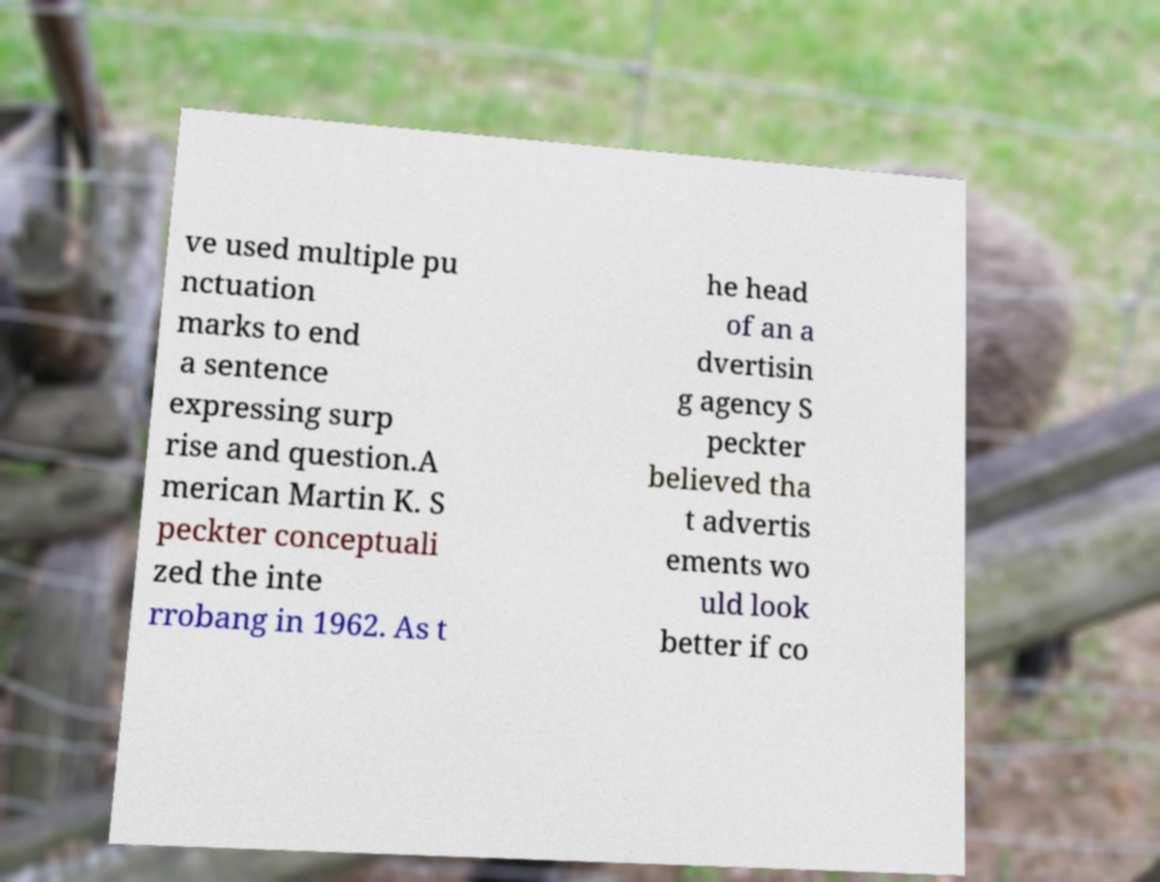Please read and relay the text visible in this image. What does it say? ve used multiple pu nctuation marks to end a sentence expressing surp rise and question.A merican Martin K. S peckter conceptuali zed the inte rrobang in 1962. As t he head of an a dvertisin g agency S peckter believed tha t advertis ements wo uld look better if co 